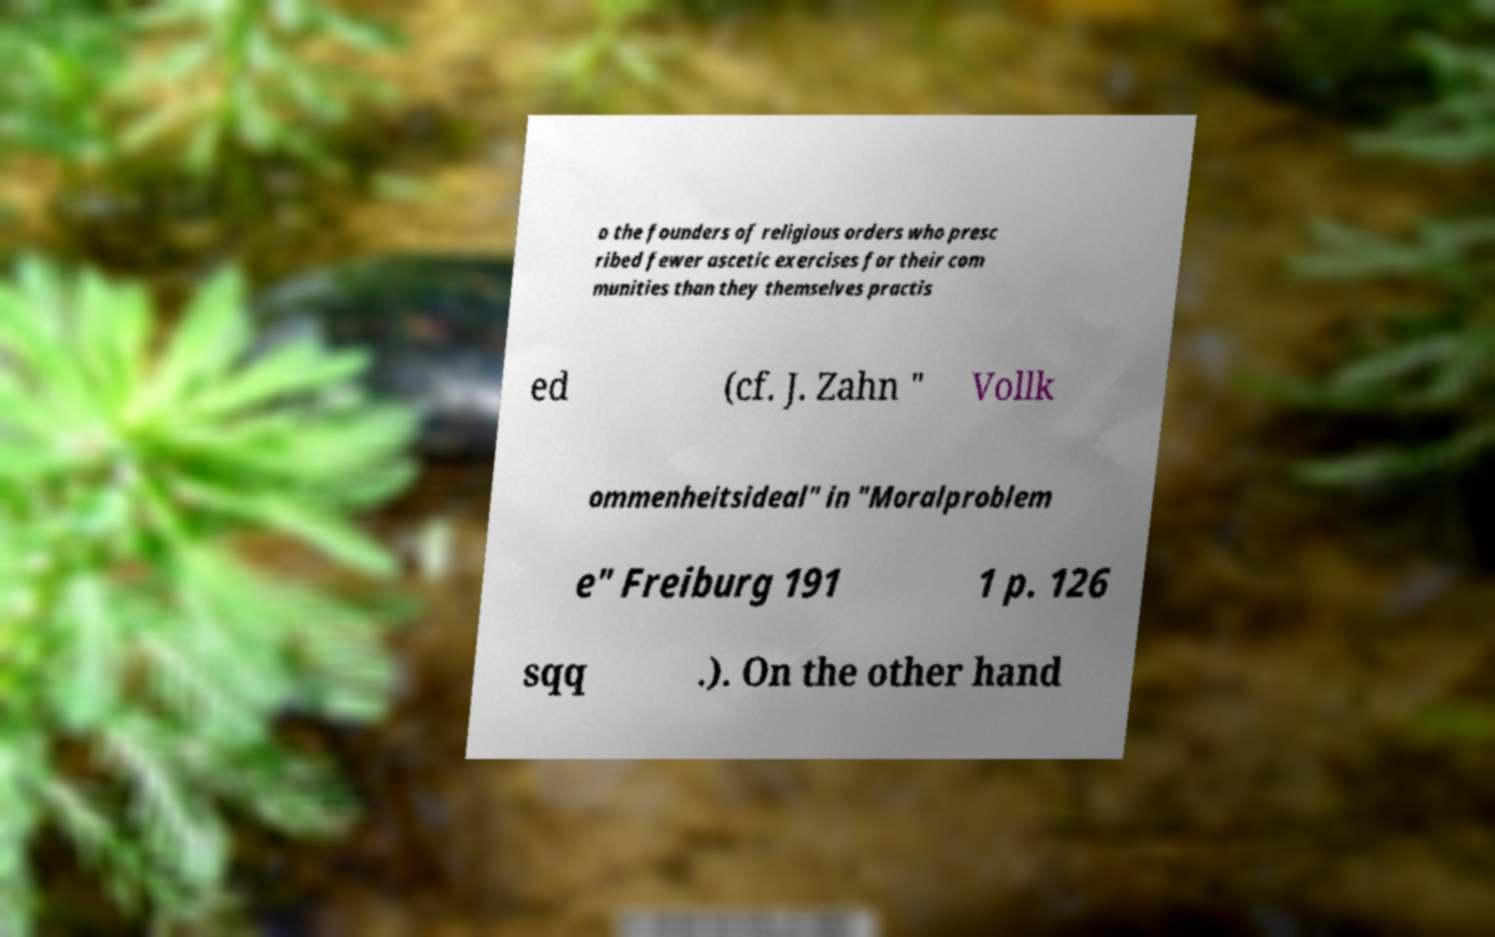Please identify and transcribe the text found in this image. o the founders of religious orders who presc ribed fewer ascetic exercises for their com munities than they themselves practis ed (cf. J. Zahn " Vollk ommenheitsideal" in "Moralproblem e" Freiburg 191 1 p. 126 sqq .). On the other hand 